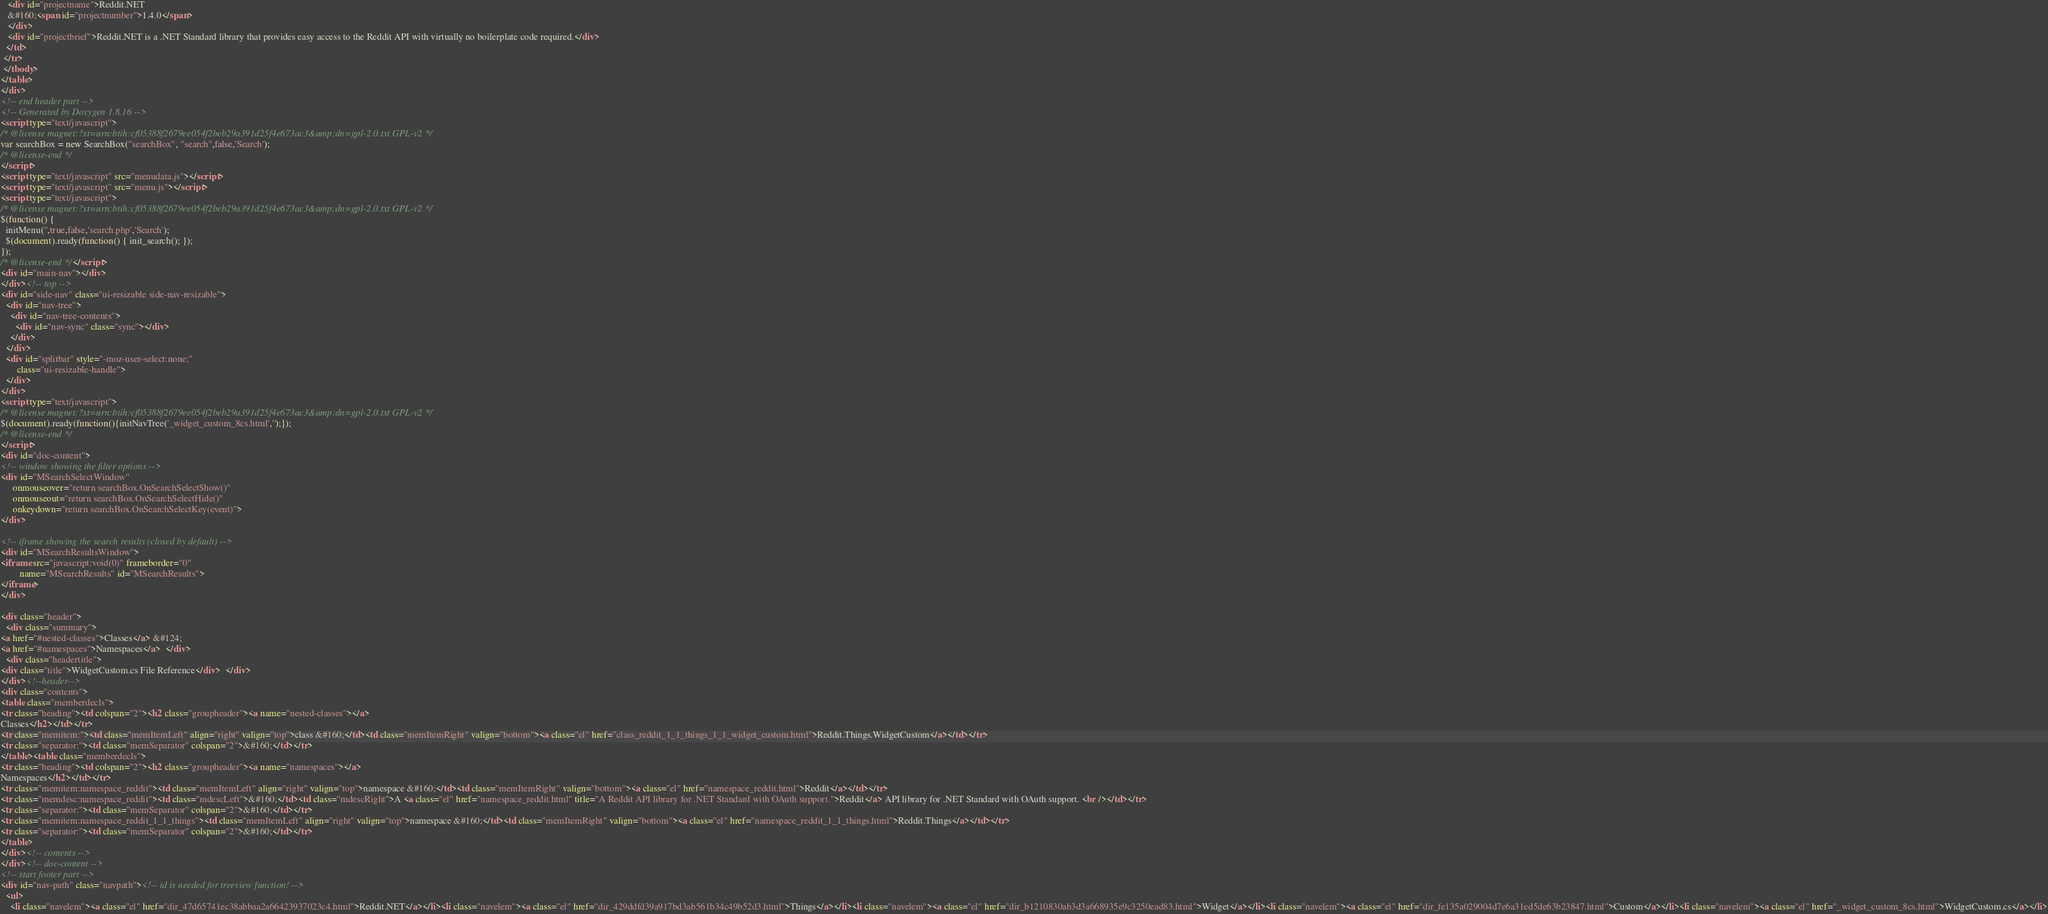Convert code to text. <code><loc_0><loc_0><loc_500><loc_500><_HTML_>   <div id="projectname">Reddit.NET
   &#160;<span id="projectnumber">1.4.0</span>
   </div>
   <div id="projectbrief">Reddit.NET is a .NET Standard library that provides easy access to the Reddit API with virtually no boilerplate code required.</div>
  </td>
 </tr>
 </tbody>
</table>
</div>
<!-- end header part -->
<!-- Generated by Doxygen 1.8.16 -->
<script type="text/javascript">
/* @license magnet:?xt=urn:btih:cf05388f2679ee054f2beb29a391d25f4e673ac3&amp;dn=gpl-2.0.txt GPL-v2 */
var searchBox = new SearchBox("searchBox", "search",false,'Search');
/* @license-end */
</script>
<script type="text/javascript" src="menudata.js"></script>
<script type="text/javascript" src="menu.js"></script>
<script type="text/javascript">
/* @license magnet:?xt=urn:btih:cf05388f2679ee054f2beb29a391d25f4e673ac3&amp;dn=gpl-2.0.txt GPL-v2 */
$(function() {
  initMenu('',true,false,'search.php','Search');
  $(document).ready(function() { init_search(); });
});
/* @license-end */</script>
<div id="main-nav"></div>
</div><!-- top -->
<div id="side-nav" class="ui-resizable side-nav-resizable">
  <div id="nav-tree">
    <div id="nav-tree-contents">
      <div id="nav-sync" class="sync"></div>
    </div>
  </div>
  <div id="splitbar" style="-moz-user-select:none;" 
       class="ui-resizable-handle">
  </div>
</div>
<script type="text/javascript">
/* @license magnet:?xt=urn:btih:cf05388f2679ee054f2beb29a391d25f4e673ac3&amp;dn=gpl-2.0.txt GPL-v2 */
$(document).ready(function(){initNavTree('_widget_custom_8cs.html','');});
/* @license-end */
</script>
<div id="doc-content">
<!-- window showing the filter options -->
<div id="MSearchSelectWindow"
     onmouseover="return searchBox.OnSearchSelectShow()"
     onmouseout="return searchBox.OnSearchSelectHide()"
     onkeydown="return searchBox.OnSearchSelectKey(event)">
</div>

<!-- iframe showing the search results (closed by default) -->
<div id="MSearchResultsWindow">
<iframe src="javascript:void(0)" frameborder="0" 
        name="MSearchResults" id="MSearchResults">
</iframe>
</div>

<div class="header">
  <div class="summary">
<a href="#nested-classes">Classes</a> &#124;
<a href="#namespaces">Namespaces</a>  </div>
  <div class="headertitle">
<div class="title">WidgetCustom.cs File Reference</div>  </div>
</div><!--header-->
<div class="contents">
<table class="memberdecls">
<tr class="heading"><td colspan="2"><h2 class="groupheader"><a name="nested-classes"></a>
Classes</h2></td></tr>
<tr class="memitem:"><td class="memItemLeft" align="right" valign="top">class &#160;</td><td class="memItemRight" valign="bottom"><a class="el" href="class_reddit_1_1_things_1_1_widget_custom.html">Reddit.Things.WidgetCustom</a></td></tr>
<tr class="separator:"><td class="memSeparator" colspan="2">&#160;</td></tr>
</table><table class="memberdecls">
<tr class="heading"><td colspan="2"><h2 class="groupheader"><a name="namespaces"></a>
Namespaces</h2></td></tr>
<tr class="memitem:namespace_reddit"><td class="memItemLeft" align="right" valign="top">namespace &#160;</td><td class="memItemRight" valign="bottom"><a class="el" href="namespace_reddit.html">Reddit</a></td></tr>
<tr class="memdesc:namespace_reddit"><td class="mdescLeft">&#160;</td><td class="mdescRight">A <a class="el" href="namespace_reddit.html" title="A Reddit API library for .NET Standard with OAuth support.">Reddit</a> API library for .NET Standard with OAuth support. <br /></td></tr>
<tr class="separator:"><td class="memSeparator" colspan="2">&#160;</td></tr>
<tr class="memitem:namespace_reddit_1_1_things"><td class="memItemLeft" align="right" valign="top">namespace &#160;</td><td class="memItemRight" valign="bottom"><a class="el" href="namespace_reddit_1_1_things.html">Reddit.Things</a></td></tr>
<tr class="separator:"><td class="memSeparator" colspan="2">&#160;</td></tr>
</table>
</div><!-- contents -->
</div><!-- doc-content -->
<!-- start footer part -->
<div id="nav-path" class="navpath"><!-- id is needed for treeview function! -->
  <ul>
    <li class="navelem"><a class="el" href="dir_47d65741ec38abbaa2a66423937023c4.html">Reddit.NET</a></li><li class="navelem"><a class="el" href="dir_429ddfd39a917bd3ab561b34c49b52d3.html">Things</a></li><li class="navelem"><a class="el" href="dir_b1210830ab3d3a668935e9c3250ead83.html">Widget</a></li><li class="navelem"><a class="el" href="dir_fe135a029004d7e6a31ed5de63b23847.html">Custom</a></li><li class="navelem"><a class="el" href="_widget_custom_8cs.html">WidgetCustom.cs</a></li></code> 